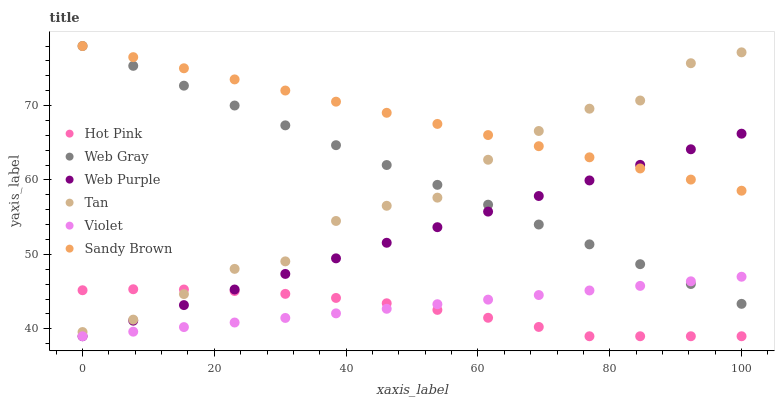Does Hot Pink have the minimum area under the curve?
Answer yes or no. Yes. Does Sandy Brown have the maximum area under the curve?
Answer yes or no. Yes. Does Web Purple have the minimum area under the curve?
Answer yes or no. No. Does Web Purple have the maximum area under the curve?
Answer yes or no. No. Is Sandy Brown the smoothest?
Answer yes or no. Yes. Is Tan the roughest?
Answer yes or no. Yes. Is Hot Pink the smoothest?
Answer yes or no. No. Is Hot Pink the roughest?
Answer yes or no. No. Does Hot Pink have the lowest value?
Answer yes or no. Yes. Does Tan have the lowest value?
Answer yes or no. No. Does Sandy Brown have the highest value?
Answer yes or no. Yes. Does Web Purple have the highest value?
Answer yes or no. No. Is Hot Pink less than Web Gray?
Answer yes or no. Yes. Is Sandy Brown greater than Hot Pink?
Answer yes or no. Yes. Does Web Purple intersect Violet?
Answer yes or no. Yes. Is Web Purple less than Violet?
Answer yes or no. No. Is Web Purple greater than Violet?
Answer yes or no. No. Does Hot Pink intersect Web Gray?
Answer yes or no. No. 